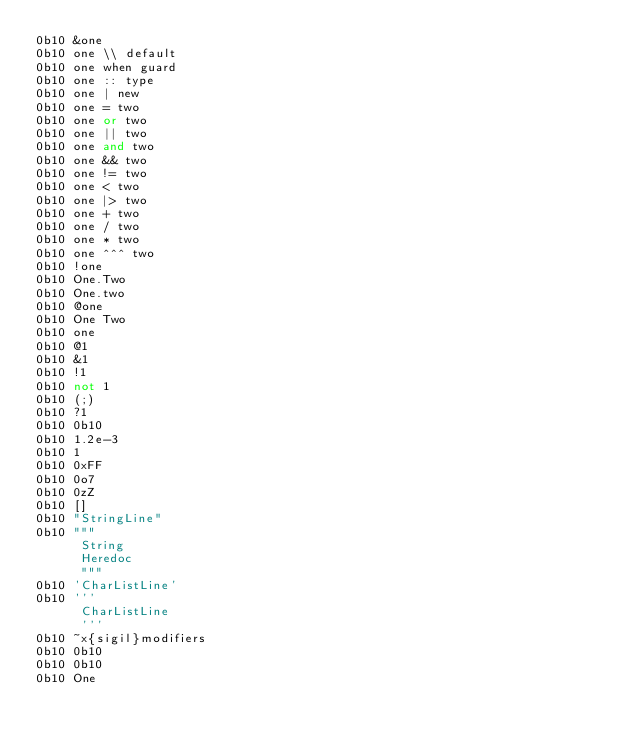Convert code to text. <code><loc_0><loc_0><loc_500><loc_500><_Elixir_>0b10 &one
0b10 one \\ default
0b10 one when guard
0b10 one :: type
0b10 one | new
0b10 one = two
0b10 one or two
0b10 one || two
0b10 one and two
0b10 one && two
0b10 one != two
0b10 one < two
0b10 one |> two
0b10 one + two
0b10 one / two
0b10 one * two
0b10 one ^^^ two
0b10 !one
0b10 One.Two
0b10 One.two
0b10 @one
0b10 One Two
0b10 one
0b10 @1
0b10 &1
0b10 !1
0b10 not 1
0b10 (;)
0b10 ?1
0b10 0b10
0b10 1.2e-3
0b10 1
0b10 0xFF
0b10 0o7
0b10 0zZ
0b10 []
0b10 "StringLine"
0b10 """
      String
      Heredoc
      """
0b10 'CharListLine'
0b10 '''
      CharListLine
      '''
0b10 ~x{sigil}modifiers
0b10 0b10
0b10 0b10
0b10 One
</code> 